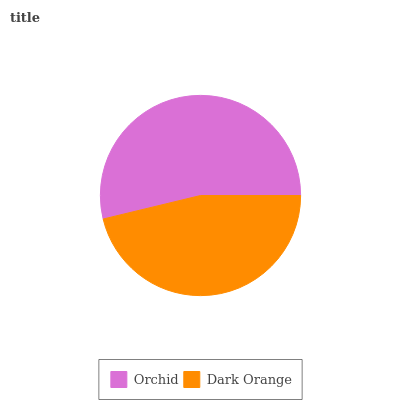Is Dark Orange the minimum?
Answer yes or no. Yes. Is Orchid the maximum?
Answer yes or no. Yes. Is Dark Orange the maximum?
Answer yes or no. No. Is Orchid greater than Dark Orange?
Answer yes or no. Yes. Is Dark Orange less than Orchid?
Answer yes or no. Yes. Is Dark Orange greater than Orchid?
Answer yes or no. No. Is Orchid less than Dark Orange?
Answer yes or no. No. Is Orchid the high median?
Answer yes or no. Yes. Is Dark Orange the low median?
Answer yes or no. Yes. Is Dark Orange the high median?
Answer yes or no. No. Is Orchid the low median?
Answer yes or no. No. 